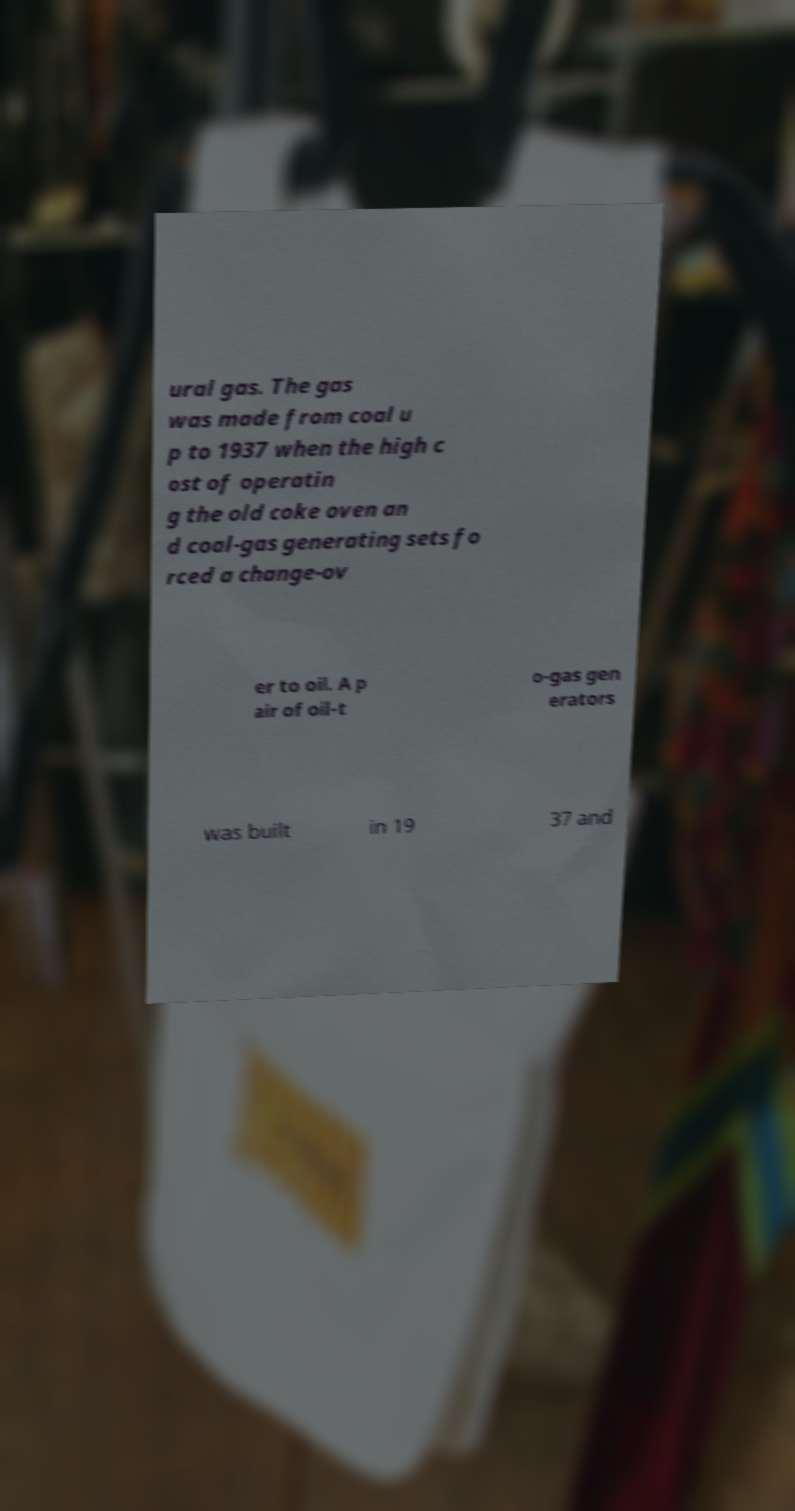For documentation purposes, I need the text within this image transcribed. Could you provide that? ural gas. The gas was made from coal u p to 1937 when the high c ost of operatin g the old coke oven an d coal-gas generating sets fo rced a change-ov er to oil. A p air of oil-t o-gas gen erators was built in 19 37 and 